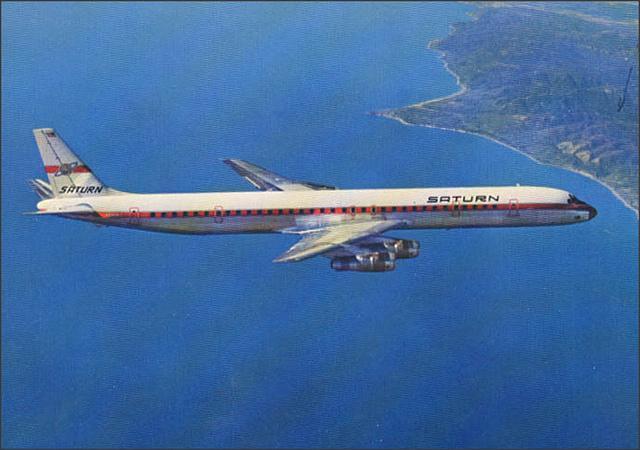How many birds are in the photo?
Give a very brief answer. 0. 